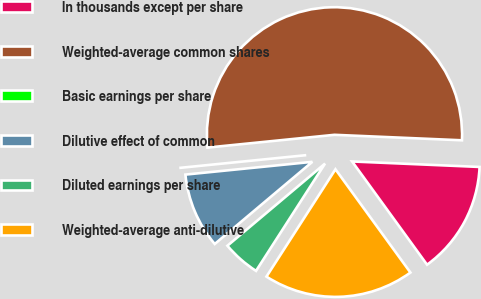Convert chart. <chart><loc_0><loc_0><loc_500><loc_500><pie_chart><fcel>In thousands except per share<fcel>Weighted-average common shares<fcel>Basic earnings per share<fcel>Dilutive effect of common<fcel>Diluted earnings per share<fcel>Weighted-average anti-dilutive<nl><fcel>14.32%<fcel>52.28%<fcel>0.0%<fcel>9.54%<fcel>4.77%<fcel>19.09%<nl></chart> 